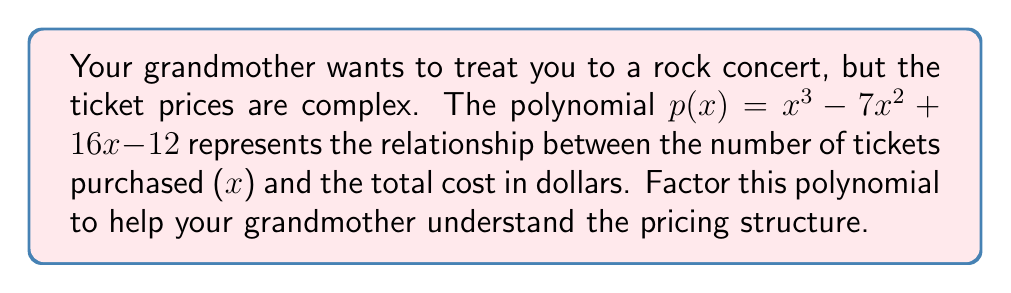Show me your answer to this math problem. To factor the polynomial $p(x) = x^3 - 7x^2 + 16x - 12$, we'll follow these steps:

1) First, let's check if there's a common factor. In this case, there isn't.

2) Next, we'll use the rational root theorem to find possible roots. The possible rational roots are the factors of the constant term (12): ±1, ±2, ±3, ±4, ±6, ±12.

3) Let's test these values. We find that p(1) = 0, so (x - 1) is a factor.

4) Divide p(x) by (x - 1) using polynomial long division:

   $x^3 - 7x^2 + 16x - 12 = (x - 1)(x^2 - 6x + 12)$

5) Now we need to factor the quadratic $x^2 - 6x + 12$. Let's use the quadratic formula:

   $x = \frac{-b \pm \sqrt{b^2 - 4ac}}{2a}$

   Here, $a=1$, $b=-6$, and $c=12$

   $x = \frac{6 \pm \sqrt{36 - 48}}{2} = \frac{6 \pm \sqrt{-12}}{2}$

6) Since we get complex roots, the quadratic $x^2 - 6x + 12$ can't be factored further over the real numbers.

Therefore, the complete factorization is:

$p(x) = (x - 1)(x^2 - 6x + 12)$
Answer: $(x - 1)(x^2 - 6x + 12)$ 